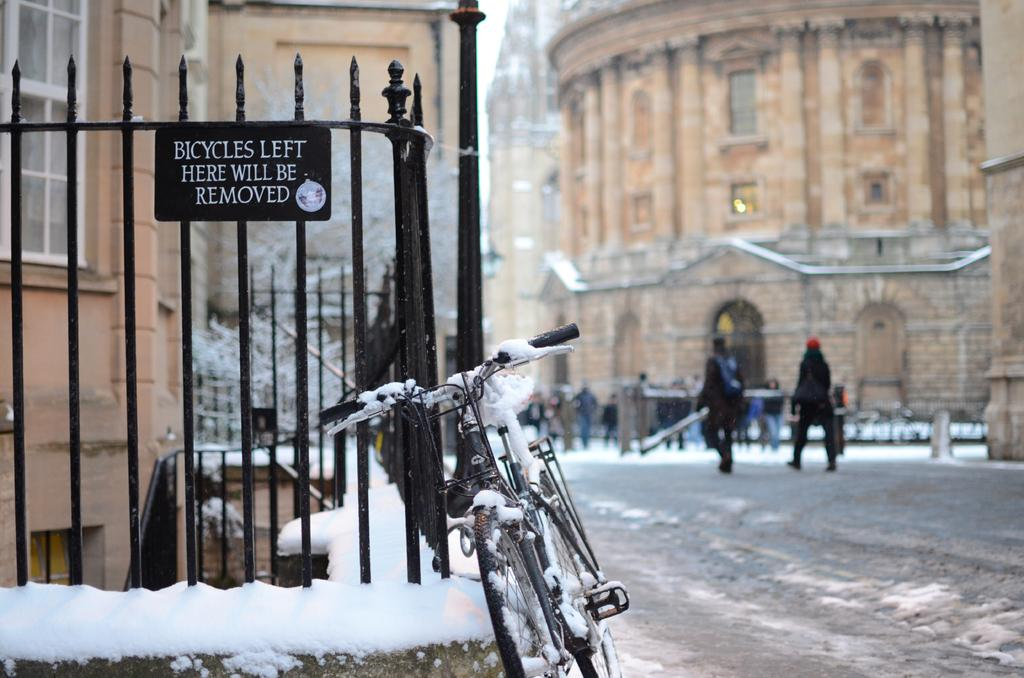What type of fence is visible in the image? There is a black color fence in the image. What mode of transportation can be seen in the image? There is a bicycle in the image. What activity are the people in the image engaged in? There are people walking in the image. What type of structures are present in the image? There are buildings in the image. Can you see a plantation of clover in the image? There is no plantation or clover present in the image. Is there any popcorn visible in the image? There is no popcorn present in the image. 